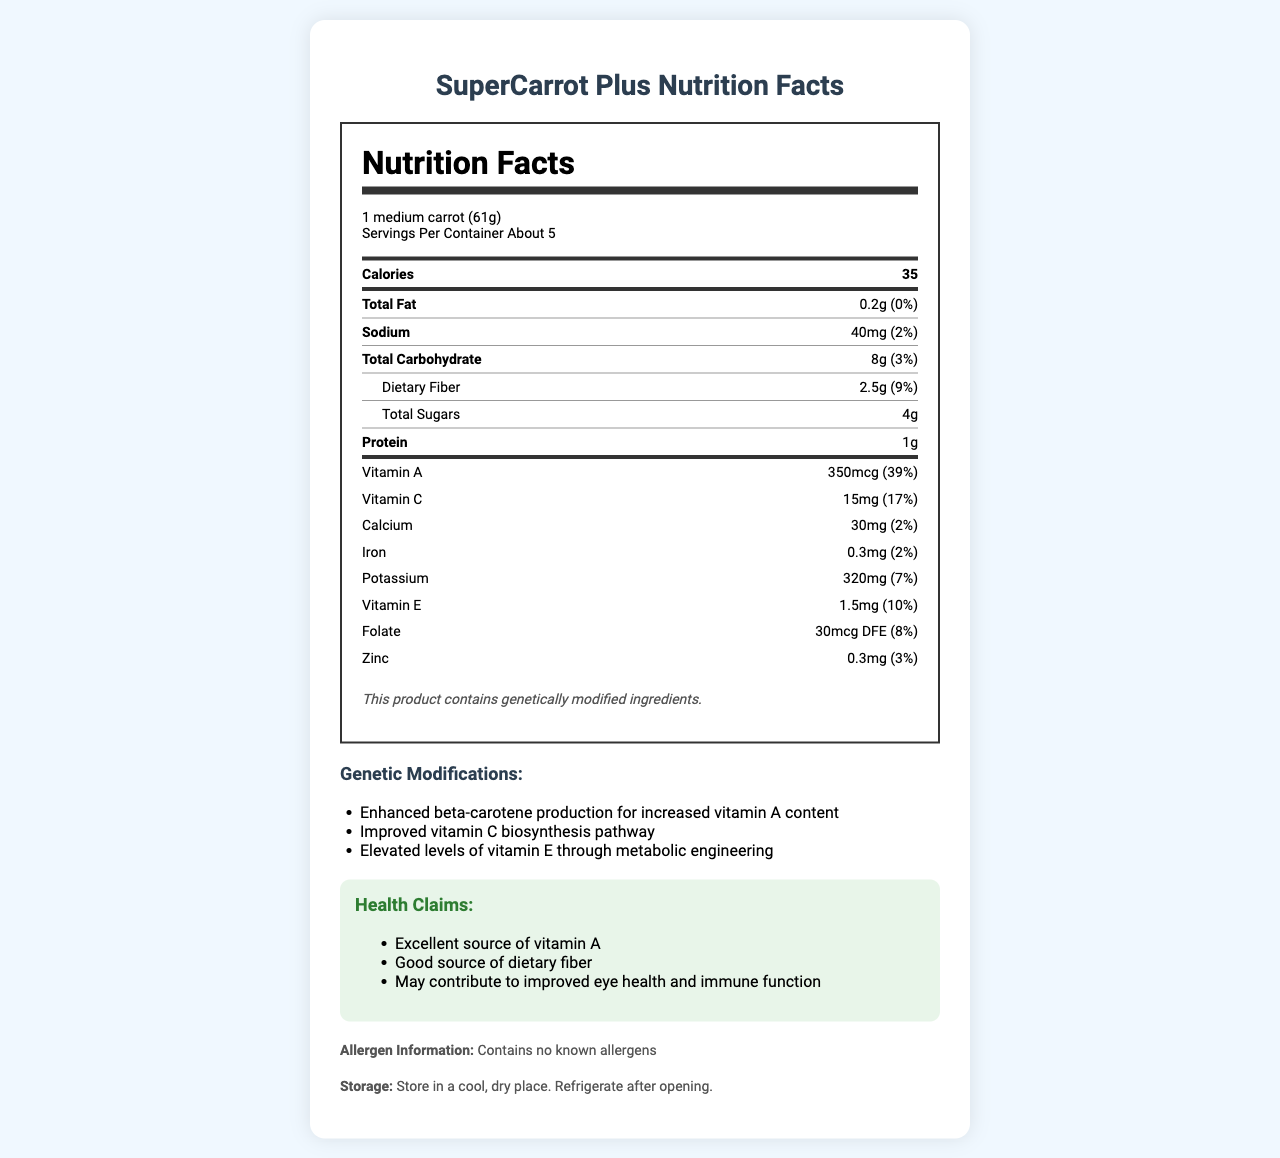what is the product name? The product name is clearly stated at the top of the document and in the title.
Answer: SuperCarrot Plus what is the serving size for SuperCarrot Plus? The serving size is listed at the beginning of the nutrition label under the heading "Nutrition Facts."
Answer: 1 medium carrot (61g) how many servings are in a container? The number of servings per container is noted just below the serving size information.
Answer: About 5 how many calories are in one serving of SuperCarrot Plus? The calorie content per serving is displayed prominently in the nutrition label.
Answer: 35 how much dietary fiber does one serving contain? The amount of dietary fiber per serving is shown within the 'Total Carbohydrate' section.
Answer: 2.5g how much vitamin A is in one serving, and what percentage of the daily value does it cover? The vitamin A content and its daily value percentage are listed under the "Vitamin A" section of the nutrition label.
Answer: 350mcg, 39% what is the percentage of daily value for vitamin C per serving? The percentage of daily value for vitamin C is found in the "Vitamin C" section.
Answer: 17% which of the following is NOT a genetic modification listed for SuperCarrot Plus? A. Enhanced beta-carotene production B. Improved vitamin C biosynthesis pathway C. Increased calcium absorption D. Elevated levels of vitamin E Increased calcium absorption is not listed among the genetic modifications.
Answer: C which nutrient has the highest daily value percentage in one serving of SuperCarrot Plus? A. Fiber B. Vitamin E C. Vitamin C D. Vitamin A Vitamin A has the highest daily value percentage at 39%, as noted in its respective section.
Answer: D is SuperCarrot Plus free from known allergens? The allergen information section states that it contains no known allergens.
Answer: Yes are any minerals present in SuperCarrot Plus? The nutrition label lists calcium, iron, potassium, and zinc as present minerals.
Answer: Yes what are the health claims associated with SuperCarrot Plus? The health claims section outlines these three specific benefits.
Answer: Excellent source of vitamin A, Good source of dietary fiber, May contribute to improved eye health and immune function describe the main idea of the document. The document provides an in-depth look at the nutritional profile, genetic enhancements, and various health benefits associated with the product, as well as practical information for consumers.
Answer: The document is a nutrition facts label for SuperCarrot Plus, a genetically modified carrot designed to have increased nutritional value. It includes detailed nutritional information, genetic modifications, health claims, allergen information, and storage instructions. how were the nutritional profiles validated for SuperCarrot Plus? The document mentions that the nutritional profile was validated by independent laboratories, but it does not provide specifics on the methodologies used for validation.
Answer: Not enough information 